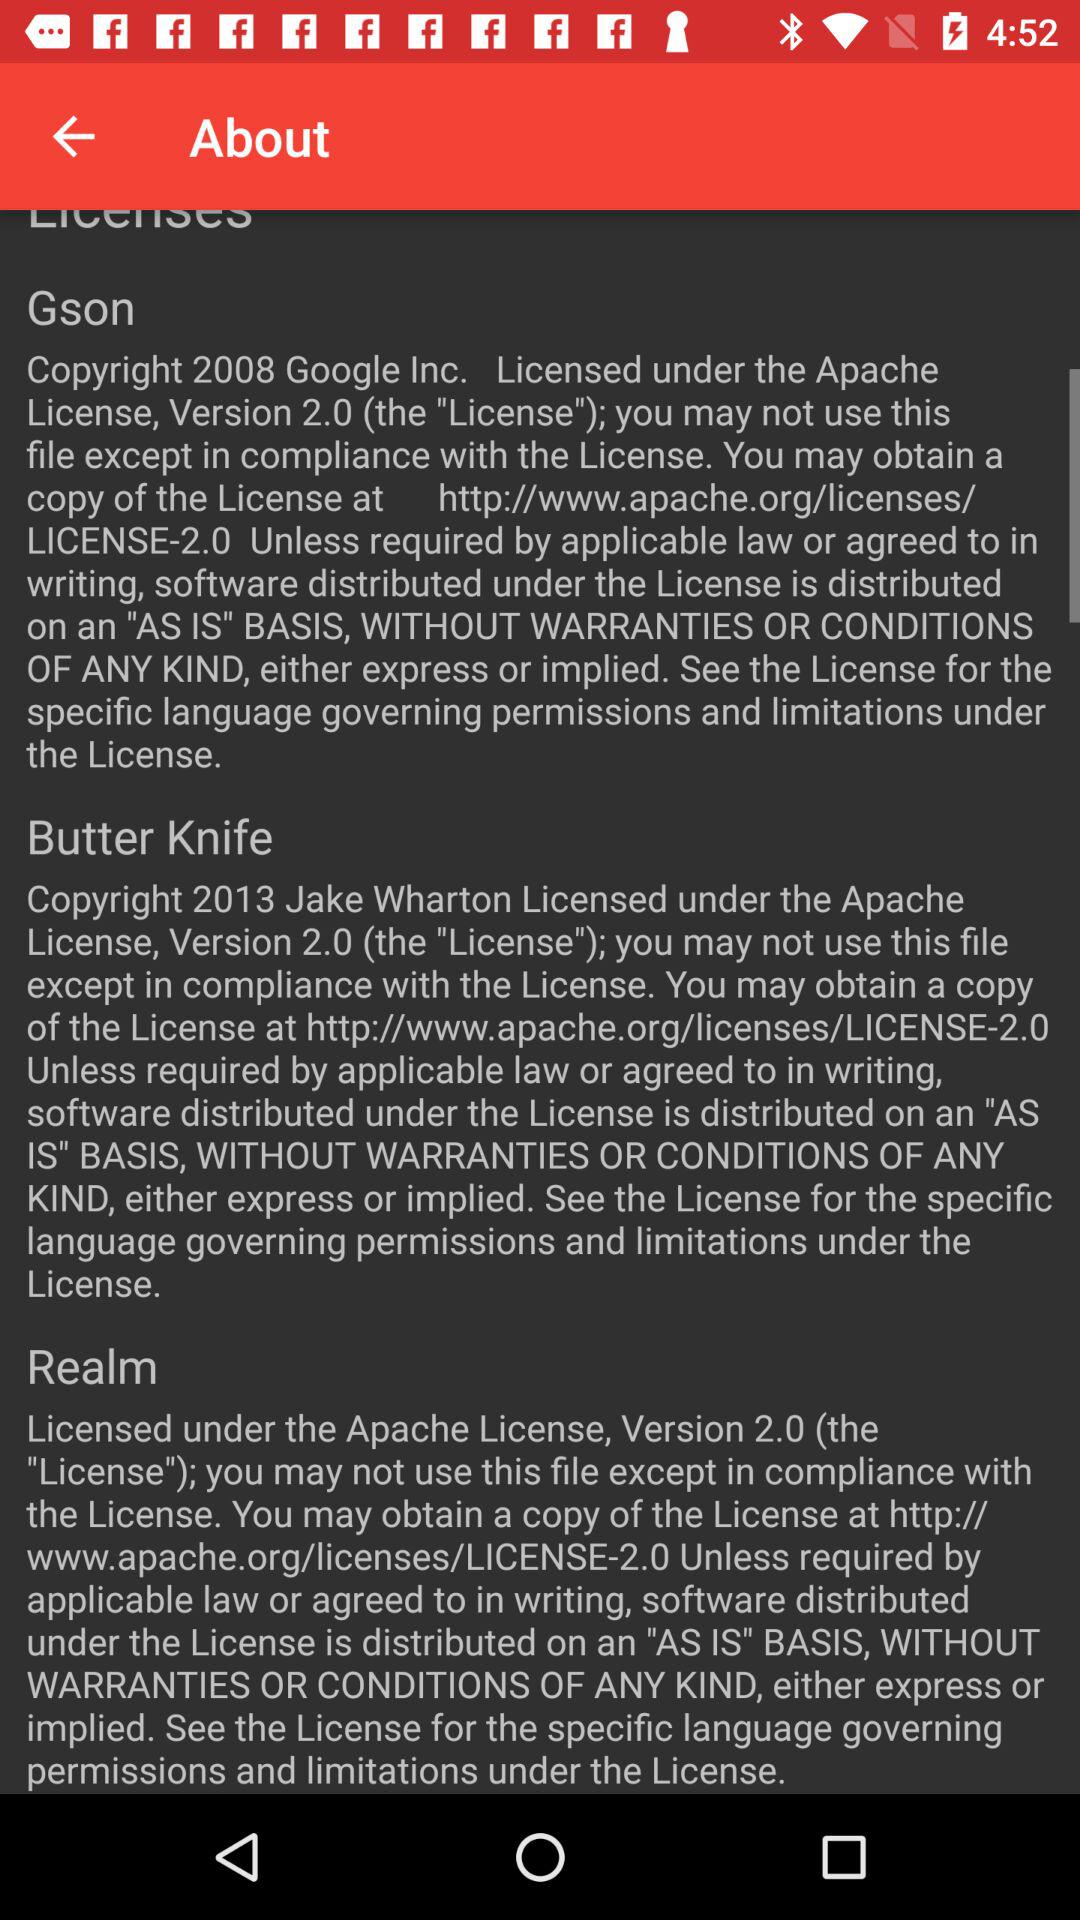Who is the developer of the butter knife? The developer is Jake Wharton. 